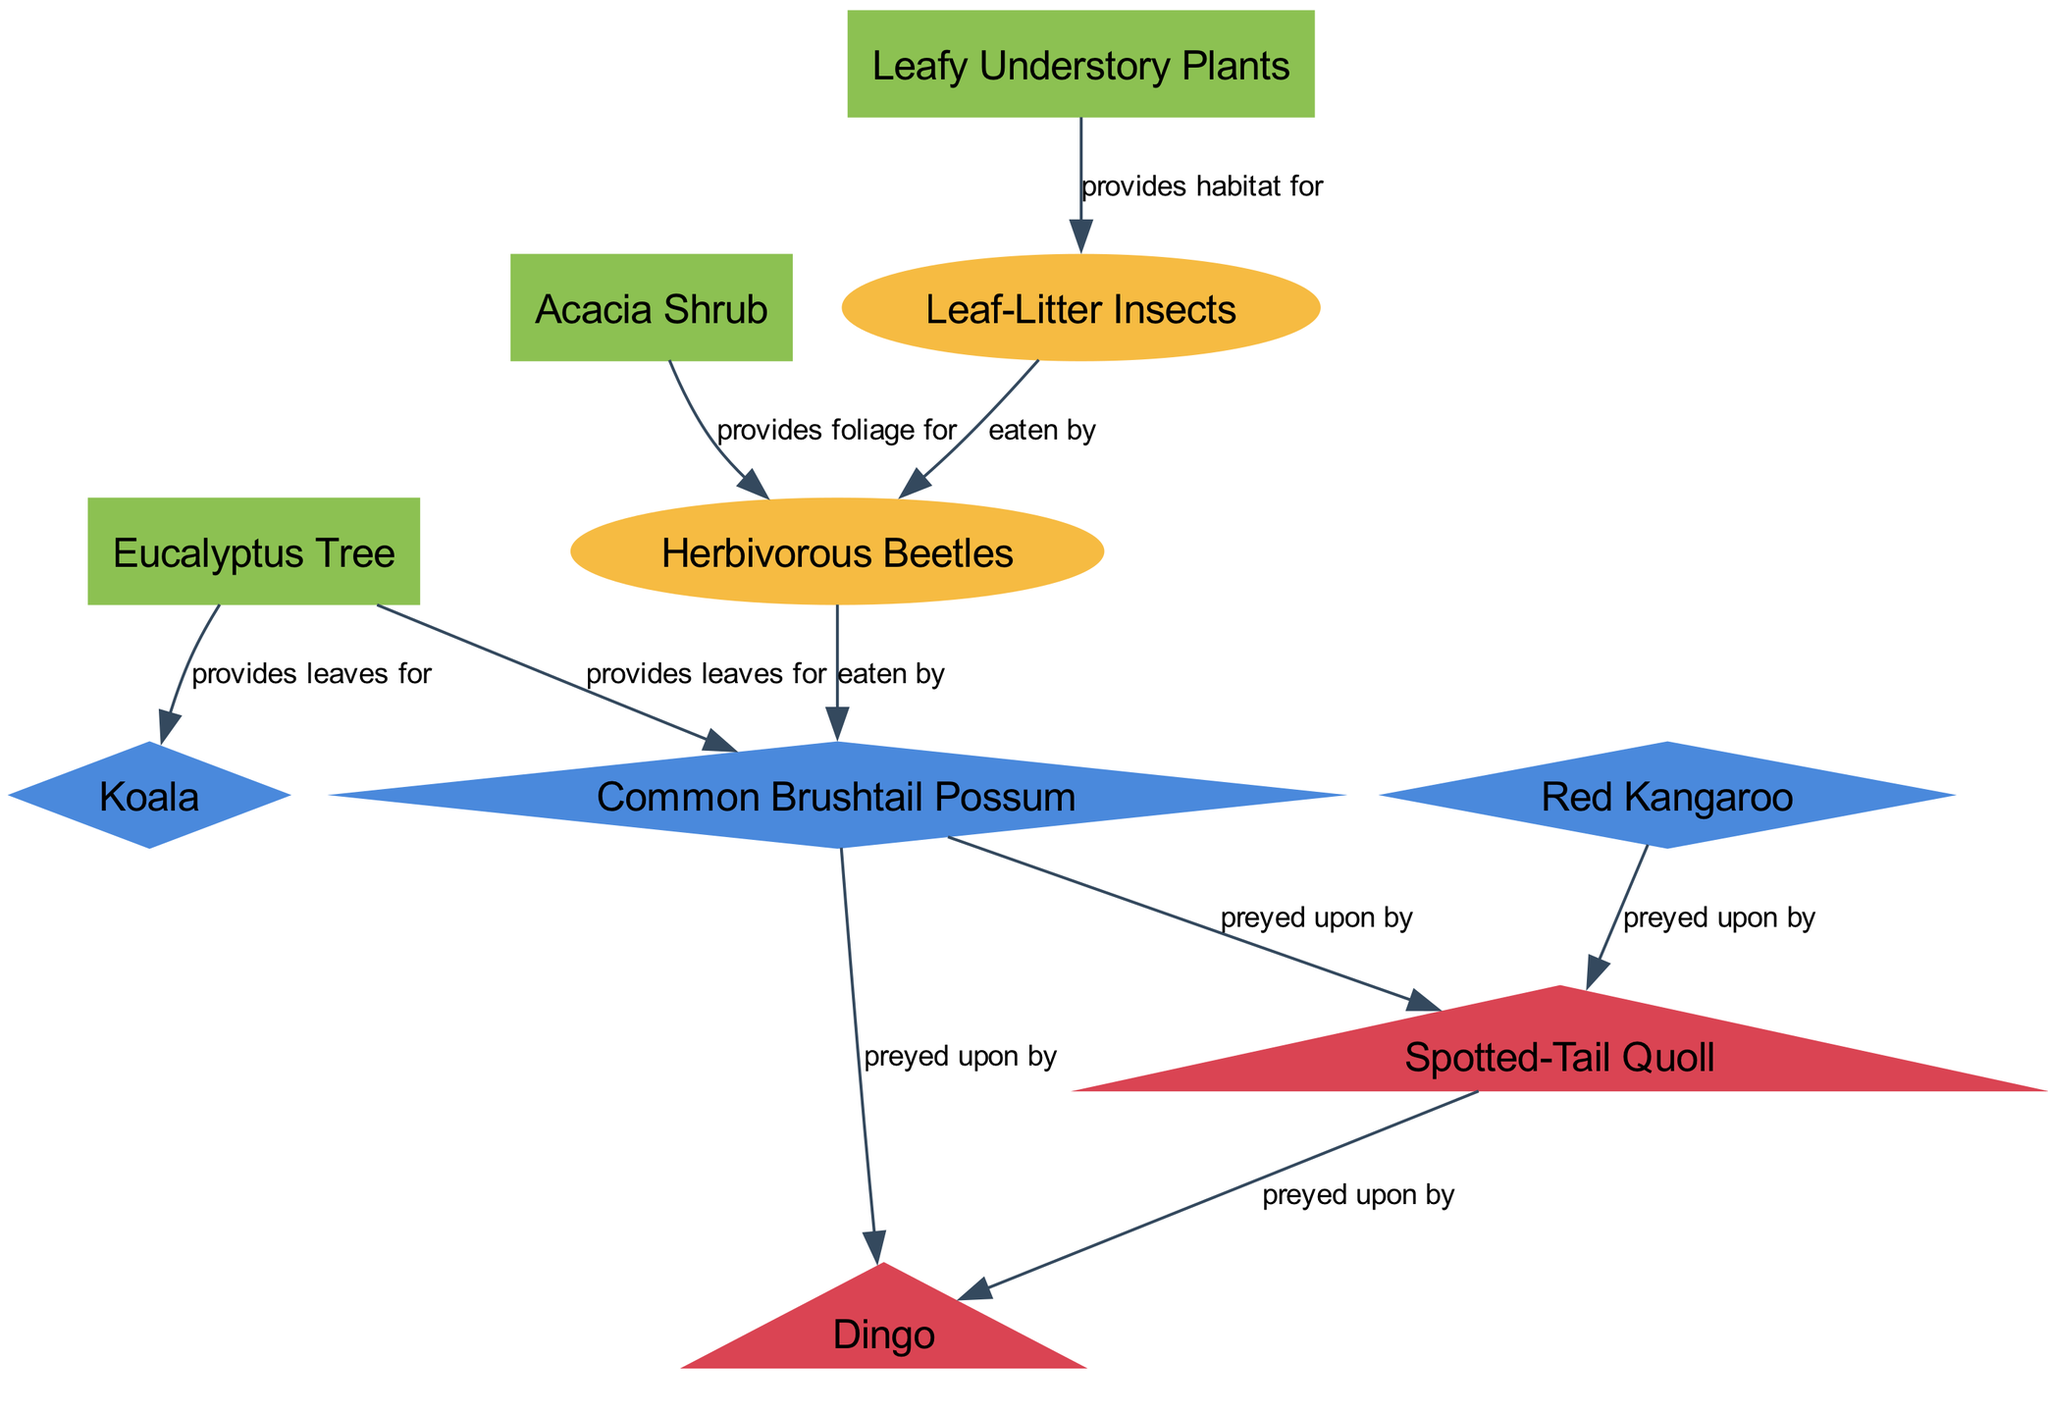What is the first level of the food chain in this diagram? The first level of the food chain consists of primary producers, which are the Eucalyptus Tree and Acacia Shrub. These are the plants that provide energy for herbivores.
Answer: Eucalyptus Tree, Acacia Shrub How many herbivores are present in the food chain? The herbivores identified in the diagram are the Koala, Common Brushtail Possum, and Red Kangaroo, which means there are three distinct herbivores.
Answer: 3 Who preys on the Common Brushtail Possum? From the diagram, we can see that both the Spotted-Tail Quoll and the Dingo prey on the Common Brushtail Possum, thus indicating a dual predation relationship.
Answer: Spotted-Tail Quoll, Dingo Which node provides habitat for Leaf-Litter Insects? The Leafy Understory Plants provide habitat for Leaf-Litter Insects, as indicated by the directed edge labeled "provides habitat for." This connection represents the ecological relationship between the two nodes.
Answer: Leafy Understory Plants What is the relationship between Leaf-Litter Insects and Herbivorous Beetles? The diagram shows that Leaf-Litter Insects are eaten by Herbivorous Beetles, indicating a predatory relationship where Leaf-Litter Insects serve as prey for these beetles.
Answer: eaten by Which organism is at the top of the food chain in this diagram? The Dingo is depicted as the top predator in the food chain, as it is preyed upon by no other organisms and based on its position in the diagram.
Answer: Dingo How many total nodes are present in the diagram? By counting all the unique entities displayed in the diagram, we find there are ten nodes in total, including plants, insects, herbivores, and carnivores.
Answer: 10 What type of relationship exists between Red Kangaroo and Spotted-Tail Quoll? The relationship depicted is that the Spotted-Tail Quoll preys upon the Red Kangaroo, showing a direct predator-prey dynamic between these species.
Answer: preyed upon by Which two plants provide leaves for herbivores? The Eucalyptus Tree and Acacia Shrub both provide leaves that serve as food for the herbivores Koala and Common Brushtail Possum, showcasing their role in the ecosystem as primary producers.
Answer: Eucalyptus Tree, Acacia Shrub 